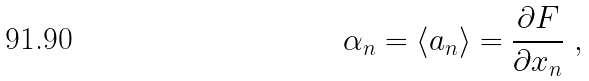<formula> <loc_0><loc_0><loc_500><loc_500>\alpha _ { n } = \left \langle a _ { n } \right \rangle = \frac { \partial F } { \partial x _ { n } } \ ,</formula> 